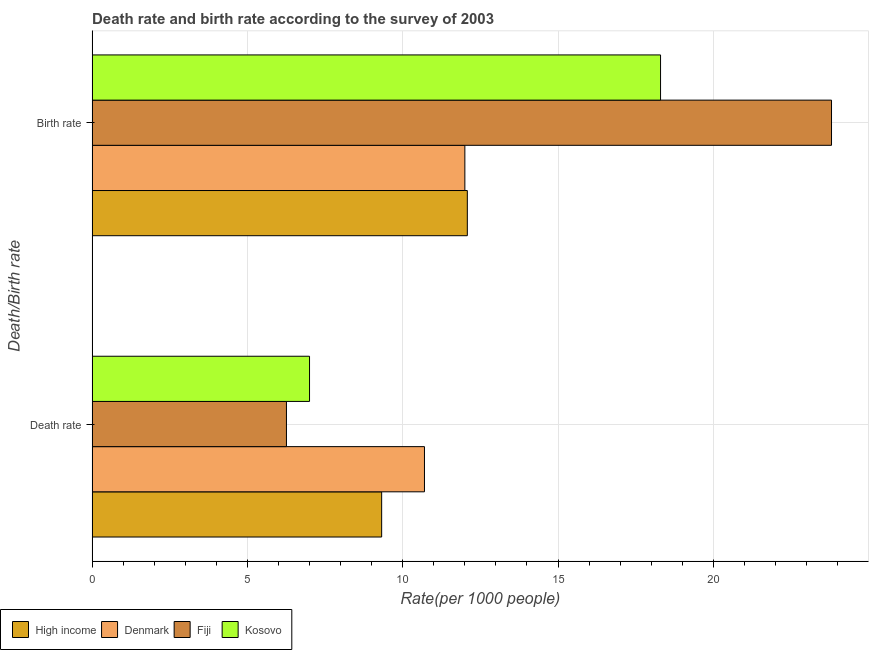How many different coloured bars are there?
Your answer should be compact. 4. How many groups of bars are there?
Your answer should be very brief. 2. Are the number of bars per tick equal to the number of legend labels?
Provide a succinct answer. Yes. How many bars are there on the 2nd tick from the top?
Keep it short and to the point. 4. How many bars are there on the 1st tick from the bottom?
Provide a short and direct response. 4. What is the label of the 2nd group of bars from the top?
Your answer should be compact. Death rate. Across all countries, what is the maximum death rate?
Your response must be concise. 10.7. Across all countries, what is the minimum death rate?
Make the answer very short. 6.26. In which country was the birth rate minimum?
Make the answer very short. Denmark. What is the total death rate in the graph?
Your response must be concise. 33.28. What is the difference between the death rate in Fiji and that in Kosovo?
Provide a succinct answer. -0.74. What is the difference between the birth rate in High income and the death rate in Fiji?
Ensure brevity in your answer.  5.82. What is the average birth rate per country?
Offer a very short reply. 16.55. What is the difference between the death rate and birth rate in Fiji?
Your answer should be very brief. -17.55. What is the ratio of the death rate in Kosovo to that in Fiji?
Offer a very short reply. 1.12. Is the death rate in Kosovo less than that in Fiji?
Provide a short and direct response. No. In how many countries, is the birth rate greater than the average birth rate taken over all countries?
Provide a succinct answer. 2. What does the 1st bar from the top in Death rate represents?
Ensure brevity in your answer.  Kosovo. What does the 2nd bar from the bottom in Death rate represents?
Ensure brevity in your answer.  Denmark. How many bars are there?
Your answer should be very brief. 8. Are all the bars in the graph horizontal?
Your response must be concise. Yes. Does the graph contain grids?
Ensure brevity in your answer.  Yes. How are the legend labels stacked?
Ensure brevity in your answer.  Horizontal. What is the title of the graph?
Ensure brevity in your answer.  Death rate and birth rate according to the survey of 2003. Does "Albania" appear as one of the legend labels in the graph?
Ensure brevity in your answer.  No. What is the label or title of the X-axis?
Your response must be concise. Rate(per 1000 people). What is the label or title of the Y-axis?
Offer a terse response. Death/Birth rate. What is the Rate(per 1000 people) in High income in Death rate?
Keep it short and to the point. 9.32. What is the Rate(per 1000 people) of Fiji in Death rate?
Provide a short and direct response. 6.26. What is the Rate(per 1000 people) of High income in Birth rate?
Your answer should be very brief. 12.08. What is the Rate(per 1000 people) in Denmark in Birth rate?
Offer a very short reply. 12. What is the Rate(per 1000 people) in Fiji in Birth rate?
Make the answer very short. 23.8. What is the Rate(per 1000 people) of Kosovo in Birth rate?
Offer a terse response. 18.3. Across all Death/Birth rate, what is the maximum Rate(per 1000 people) of High income?
Provide a short and direct response. 12.08. Across all Death/Birth rate, what is the maximum Rate(per 1000 people) in Denmark?
Your response must be concise. 12. Across all Death/Birth rate, what is the maximum Rate(per 1000 people) in Fiji?
Make the answer very short. 23.8. Across all Death/Birth rate, what is the minimum Rate(per 1000 people) of High income?
Offer a terse response. 9.32. Across all Death/Birth rate, what is the minimum Rate(per 1000 people) of Fiji?
Ensure brevity in your answer.  6.26. What is the total Rate(per 1000 people) in High income in the graph?
Offer a very short reply. 21.4. What is the total Rate(per 1000 people) in Denmark in the graph?
Ensure brevity in your answer.  22.7. What is the total Rate(per 1000 people) of Fiji in the graph?
Your response must be concise. 30.06. What is the total Rate(per 1000 people) of Kosovo in the graph?
Provide a succinct answer. 25.3. What is the difference between the Rate(per 1000 people) of High income in Death rate and that in Birth rate?
Provide a short and direct response. -2.76. What is the difference between the Rate(per 1000 people) in Denmark in Death rate and that in Birth rate?
Your answer should be compact. -1.3. What is the difference between the Rate(per 1000 people) of Fiji in Death rate and that in Birth rate?
Make the answer very short. -17.55. What is the difference between the Rate(per 1000 people) in Kosovo in Death rate and that in Birth rate?
Offer a very short reply. -11.3. What is the difference between the Rate(per 1000 people) of High income in Death rate and the Rate(per 1000 people) of Denmark in Birth rate?
Offer a terse response. -2.68. What is the difference between the Rate(per 1000 people) of High income in Death rate and the Rate(per 1000 people) of Fiji in Birth rate?
Keep it short and to the point. -14.48. What is the difference between the Rate(per 1000 people) in High income in Death rate and the Rate(per 1000 people) in Kosovo in Birth rate?
Ensure brevity in your answer.  -8.98. What is the difference between the Rate(per 1000 people) in Denmark in Death rate and the Rate(per 1000 people) in Fiji in Birth rate?
Provide a succinct answer. -13.1. What is the difference between the Rate(per 1000 people) of Denmark in Death rate and the Rate(per 1000 people) of Kosovo in Birth rate?
Keep it short and to the point. -7.6. What is the difference between the Rate(per 1000 people) in Fiji in Death rate and the Rate(per 1000 people) in Kosovo in Birth rate?
Your response must be concise. -12.04. What is the average Rate(per 1000 people) in High income per Death/Birth rate?
Offer a terse response. 10.7. What is the average Rate(per 1000 people) of Denmark per Death/Birth rate?
Ensure brevity in your answer.  11.35. What is the average Rate(per 1000 people) in Fiji per Death/Birth rate?
Your answer should be very brief. 15.03. What is the average Rate(per 1000 people) of Kosovo per Death/Birth rate?
Offer a terse response. 12.65. What is the difference between the Rate(per 1000 people) of High income and Rate(per 1000 people) of Denmark in Death rate?
Offer a very short reply. -1.38. What is the difference between the Rate(per 1000 people) of High income and Rate(per 1000 people) of Fiji in Death rate?
Your answer should be very brief. 3.06. What is the difference between the Rate(per 1000 people) in High income and Rate(per 1000 people) in Kosovo in Death rate?
Provide a short and direct response. 2.32. What is the difference between the Rate(per 1000 people) in Denmark and Rate(per 1000 people) in Fiji in Death rate?
Give a very brief answer. 4.44. What is the difference between the Rate(per 1000 people) of Fiji and Rate(per 1000 people) of Kosovo in Death rate?
Your response must be concise. -0.74. What is the difference between the Rate(per 1000 people) of High income and Rate(per 1000 people) of Denmark in Birth rate?
Provide a short and direct response. 0.08. What is the difference between the Rate(per 1000 people) in High income and Rate(per 1000 people) in Fiji in Birth rate?
Your response must be concise. -11.72. What is the difference between the Rate(per 1000 people) in High income and Rate(per 1000 people) in Kosovo in Birth rate?
Give a very brief answer. -6.22. What is the difference between the Rate(per 1000 people) of Denmark and Rate(per 1000 people) of Fiji in Birth rate?
Your answer should be very brief. -11.8. What is the difference between the Rate(per 1000 people) in Denmark and Rate(per 1000 people) in Kosovo in Birth rate?
Make the answer very short. -6.3. What is the difference between the Rate(per 1000 people) of Fiji and Rate(per 1000 people) of Kosovo in Birth rate?
Provide a short and direct response. 5.5. What is the ratio of the Rate(per 1000 people) of High income in Death rate to that in Birth rate?
Ensure brevity in your answer.  0.77. What is the ratio of the Rate(per 1000 people) of Denmark in Death rate to that in Birth rate?
Make the answer very short. 0.89. What is the ratio of the Rate(per 1000 people) of Fiji in Death rate to that in Birth rate?
Keep it short and to the point. 0.26. What is the ratio of the Rate(per 1000 people) in Kosovo in Death rate to that in Birth rate?
Make the answer very short. 0.38. What is the difference between the highest and the second highest Rate(per 1000 people) of High income?
Your answer should be compact. 2.76. What is the difference between the highest and the second highest Rate(per 1000 people) in Fiji?
Give a very brief answer. 17.55. What is the difference between the highest and the second highest Rate(per 1000 people) of Kosovo?
Provide a short and direct response. 11.3. What is the difference between the highest and the lowest Rate(per 1000 people) in High income?
Give a very brief answer. 2.76. What is the difference between the highest and the lowest Rate(per 1000 people) of Denmark?
Give a very brief answer. 1.3. What is the difference between the highest and the lowest Rate(per 1000 people) of Fiji?
Make the answer very short. 17.55. What is the difference between the highest and the lowest Rate(per 1000 people) of Kosovo?
Ensure brevity in your answer.  11.3. 